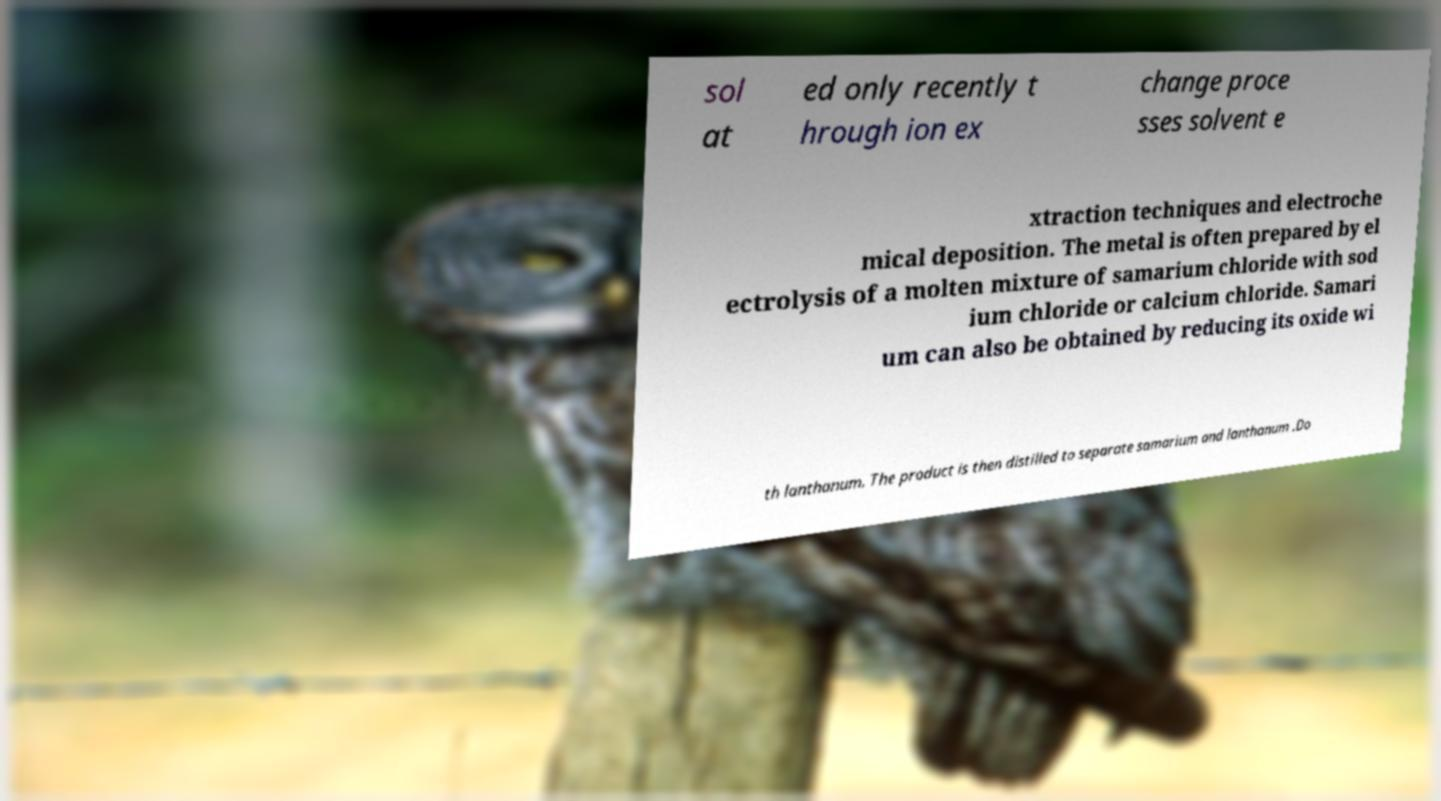There's text embedded in this image that I need extracted. Can you transcribe it verbatim? sol at ed only recently t hrough ion ex change proce sses solvent e xtraction techniques and electroche mical deposition. The metal is often prepared by el ectrolysis of a molten mixture of samarium chloride with sod ium chloride or calcium chloride. Samari um can also be obtained by reducing its oxide wi th lanthanum. The product is then distilled to separate samarium and lanthanum .Do 